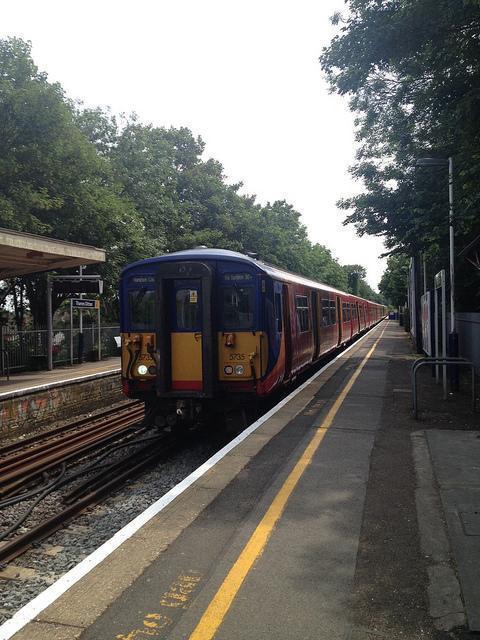How many horses do not have riders?
Give a very brief answer. 0. 